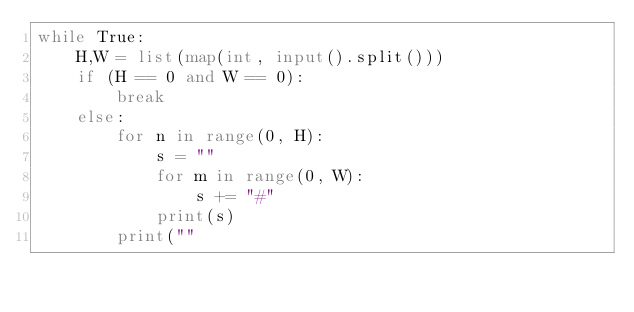<code> <loc_0><loc_0><loc_500><loc_500><_Python_>while True:
	H,W = list(map(int, input().split()))
	if (H == 0 and W == 0):
		break
	else:
		for n in range(0, H):
			s = ""
			for m in range(0, W):
				s += "#"
			print(s)
		print(""</code> 